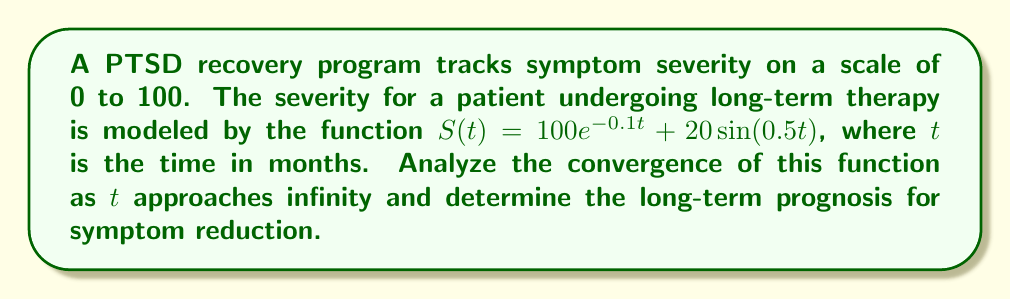Could you help me with this problem? To analyze the convergence of the symptom reduction function, we need to examine the limit of $S(t)$ as $t$ approaches infinity:

$$\lim_{t \to \infty} S(t) = \lim_{t \to \infty} (100e^{-0.1t} + 20\sin(0.5t))$$

Let's break this down into two parts:

1) $\lim_{t \to \infty} 100e^{-0.1t}$:
   As $t$ increases, $e^{-0.1t}$ approaches 0, so this term converges to 0.

2) $\lim_{t \to \infty} 20\sin(0.5t)$:
   The sine function oscillates between -1 and 1, so this term doesn't converge to a single value. However, it's bounded between -20 and 20.

Combining these results:
- The exponential term converges to 0
- The sine term continues to oscillate between -20 and 20

Therefore, in the long term, the symptom severity will oscillate between 0 and 20 on the scale, with the oscillations centered around 0.

To determine if this series converges, we can use the limit comparison test with a geometric series:

$$\lim_{t \to \infty} \frac{|S(t)|}{|r^t|} = \lim_{t \to \infty} \frac{|100e^{-0.1t} + 20\sin(0.5t)|}{|r^t|}$$

Where $0 < r < 1$. Choosing $r = e^{-0.05}$:

$$\lim_{t \to \infty} \frac{|100e^{-0.1t} + 20\sin(0.5t)|}{|e^{-0.05t}|} = \lim_{t \to \infty} |100e^{-0.05t} + 20e^{0.05t}\sin(0.5t)| = 0$$

Since this limit is 0, the original series converges by the limit comparison test.
Answer: The function converges to an oscillation between 0 and 20, centered at 0. 